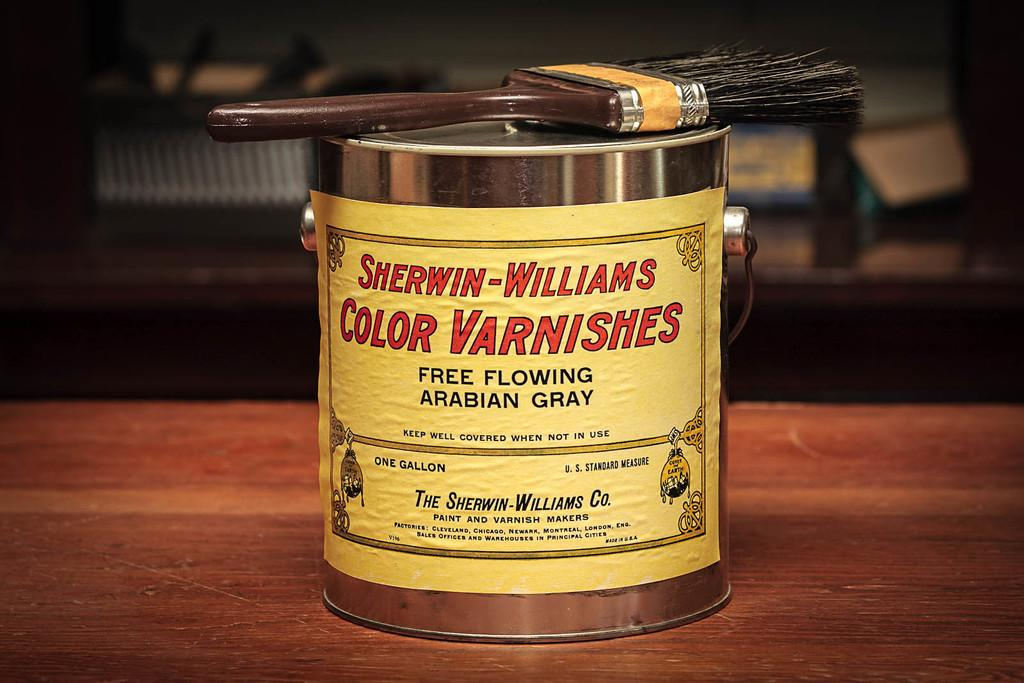<image>
Create a compact narrative representing the image presented. Container with a yellow label that says "Color Varnishes". 